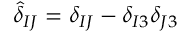<formula> <loc_0><loc_0><loc_500><loc_500>{ \hat { \delta } } _ { I J } = \delta _ { I J } - \delta _ { I 3 } \delta _ { J 3 }</formula> 